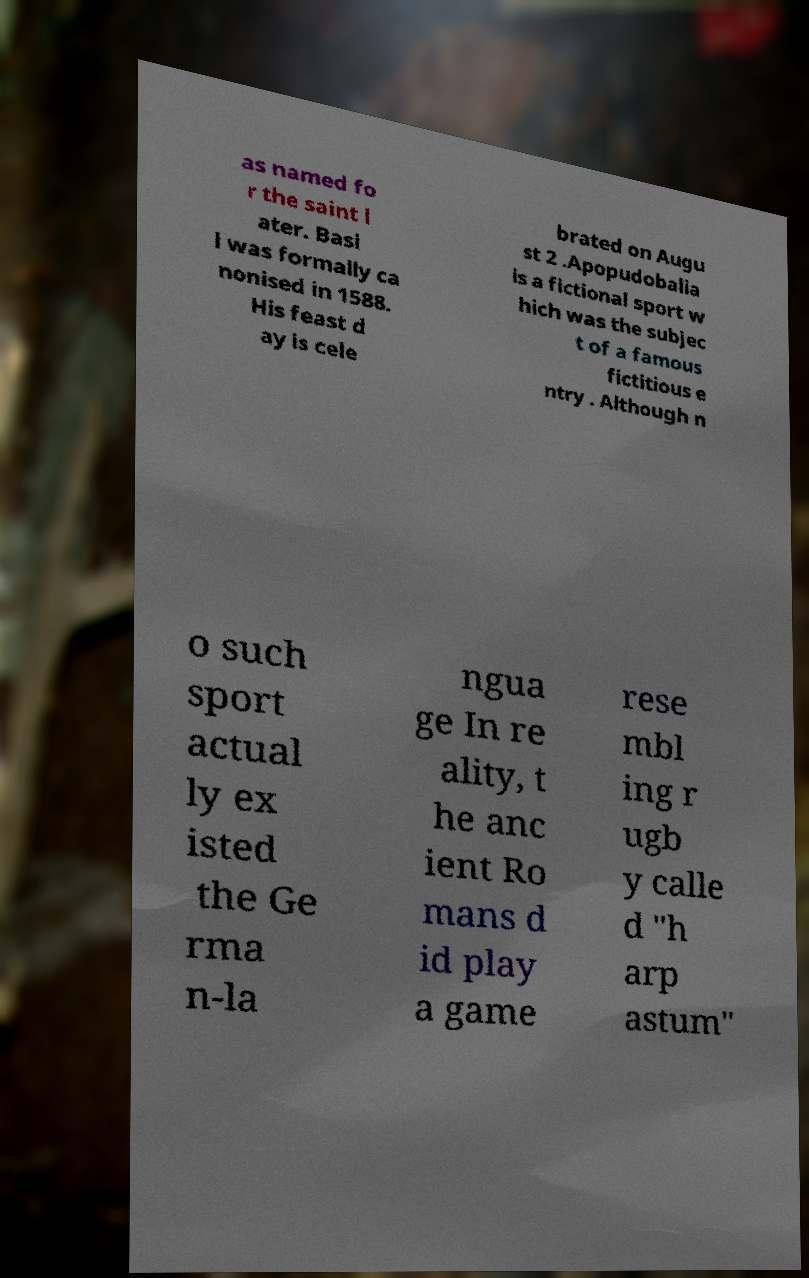Can you read and provide the text displayed in the image?This photo seems to have some interesting text. Can you extract and type it out for me? as named fo r the saint l ater. Basi l was formally ca nonised in 1588. His feast d ay is cele brated on Augu st 2 .Apopudobalia is a fictional sport w hich was the subjec t of a famous fictitious e ntry . Although n o such sport actual ly ex isted the Ge rma n-la ngua ge In re ality, t he anc ient Ro mans d id play a game rese mbl ing r ugb y calle d "h arp astum" 